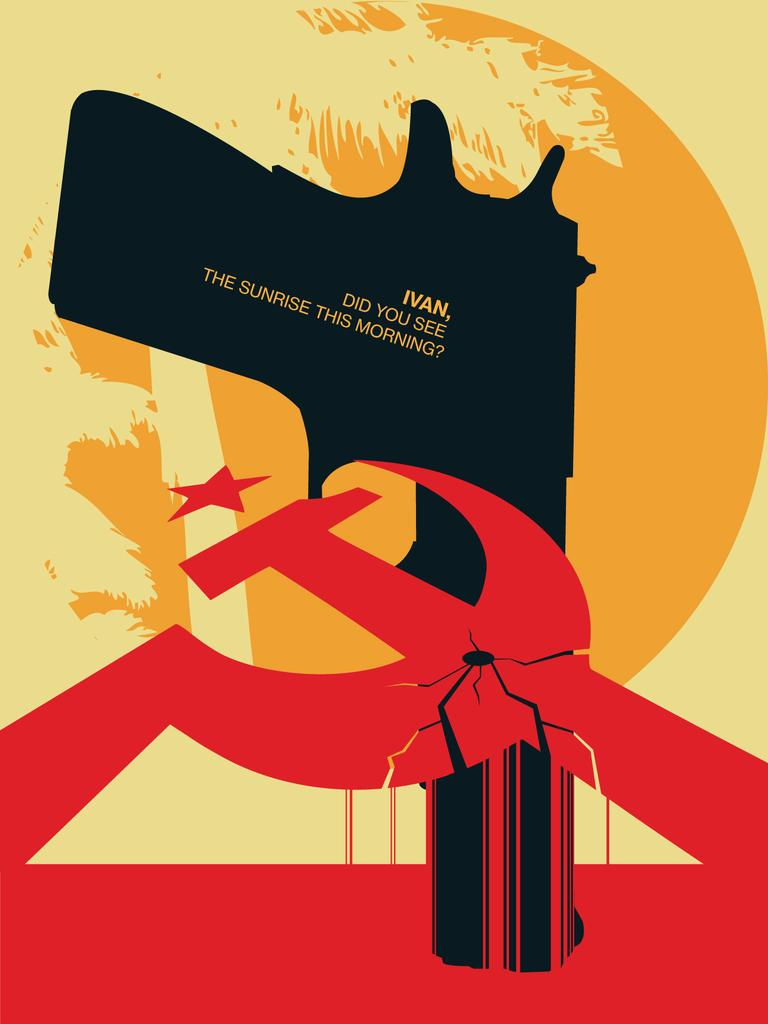What is present in the image? There is a poster in the image. What is depicted on the poster? The poster contains a black-colored gun. Are there any words on the poster? Yes, there is text on the poster. How many tickets can be seen on the poster? There are no tickets present on the poster; it features a black-colored gun and text. What type of net is used to catch the gun on the poster? There is no net present in the image, and the gun is not depicted as being caught by any net. 